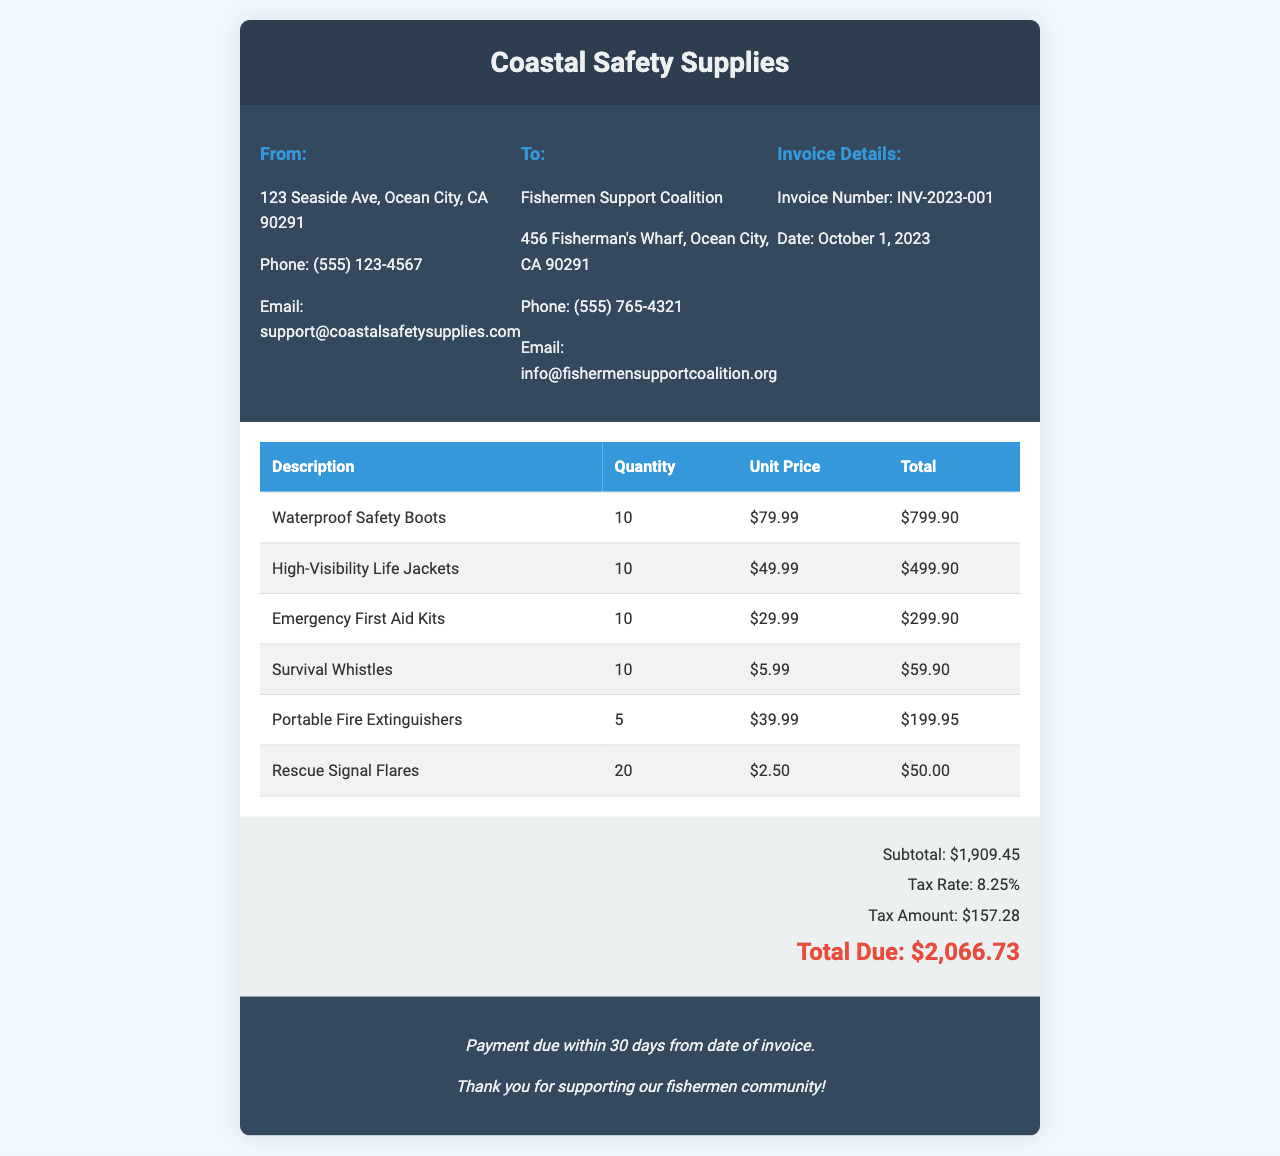What is the invoice number? The invoice number is listed in the invoice details section.
Answer: INV-2023-001 What is the date of the invoice? The date of the invoice is provided in the invoice details section.
Answer: October 1, 2023 What is the subtotal amount? The subtotal is detailed in the invoice summary section.
Answer: $1,909.45 How many waterproof safety boots were purchased? The quantity of waterproof safety boots is listed in the invoice items section.
Answer: 10 What is the tax rate applied? The tax rate is provided in the invoice summary section.
Answer: 8.25% How much is the total due? The total due is specified at the end of the invoice summary.
Answer: $2,066.73 What are the total units of emergency first aid kits purchased? The quantity of emergency first aid kits is found within the invoice items.
Answer: 10 What type of organization is listed as "To"? This section indicates the recipient organization for the invoice.
Answer: Fishermen Support Coalition What is the quantity of rescue signal flares ordered? This quantity can be found in the list of items on the invoice.
Answer: 20 